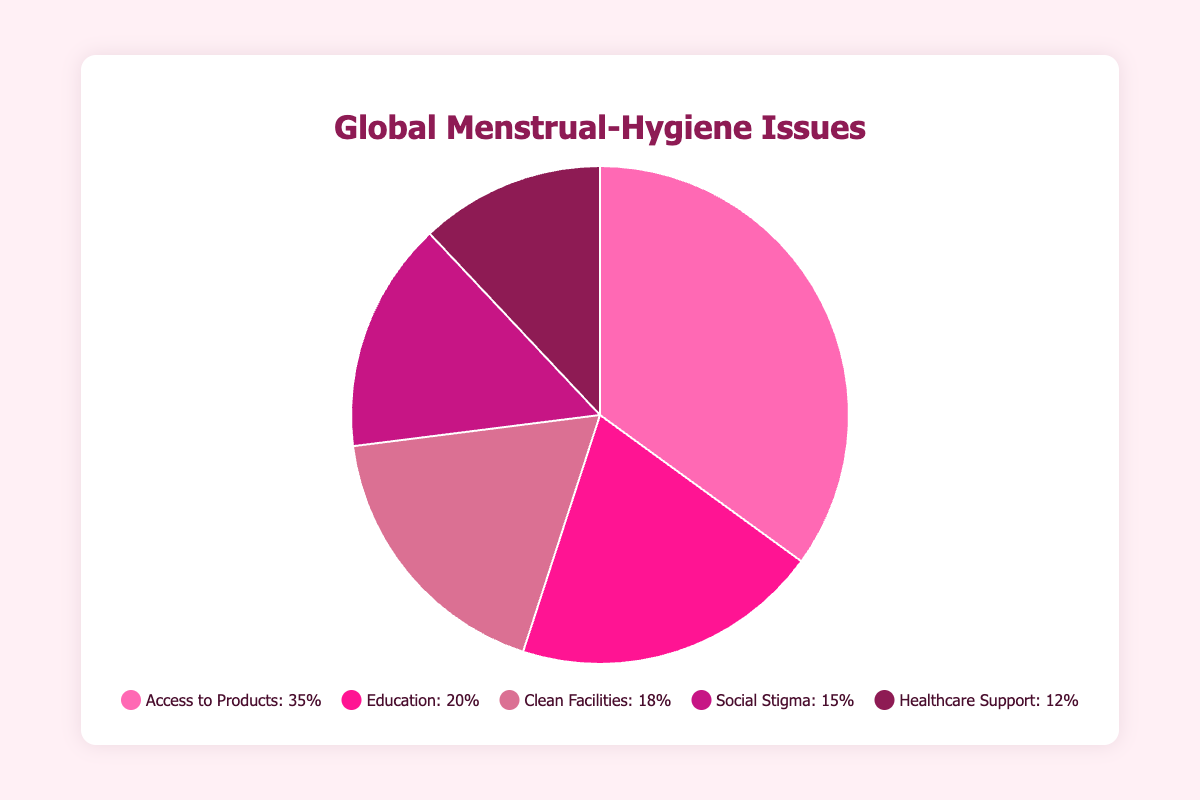Which issue has the highest percentage reported? The highest percentage reported is for "Access to Products" at 35%. This can be observed at the largest section of the pie chart, which corresponds to the "Access to Products" label.
Answer: Access to Products, 35% What is the total percentage for "Education" and "Clean Facilities"? Summing the percentages for "Education" (20%) and "Clean Facilities" (18%), we get 20 + 18 = 38%.
Answer: 38% How do the issues of "Social Stigma" and "Healthcare Support" compare in percentage terms? "Social Stigma" is 15% while "Healthcare Support" is 12%. By comparing the two percentages, we see that "Social Stigma" is 3% higher than "Healthcare Support".
Answer: Social Stigma is higher by 3% Which issue is represented by the darkest color in the chart? The darkest color in the chart represents "Healthcare Support", which is the smallest section at 12%.
Answer: Healthcare Support Arrange the issues in descending order of the reported percentage. Ordering from highest to lowest: "Access to Products" (35%), "Education" (20%), "Clean Facilities" (18%), "Social Stigma" (15%), "Healthcare Support" (12%).
Answer: Access to Products, Education, Clean Facilities, Social Stigma, Healthcare Support What's the average percentage of reported menstrual hygiene issues? Summing all percentages (35 + 20 + 18 + 15 + 12 = 100) and dividing by the number of issues (5), we get an average of 100 / 5 = 20%.
Answer: 20% What is the difference between the highest and lowest reported percentages? The highest percentage is for "Access to Products" at 35% and the lowest is for "Healthcare Support" at 12%. The difference is 35 - 12 = 23%.
Answer: 23% Which issues combined make up the majority (over 50%)? Adding the percentages of "Access to Products" (35%) and "Education" (20%), we get 35 + 20 = 55%, which is over 50%, thus these two issues combined make up the majority.
Answer: Access to Products and Education 